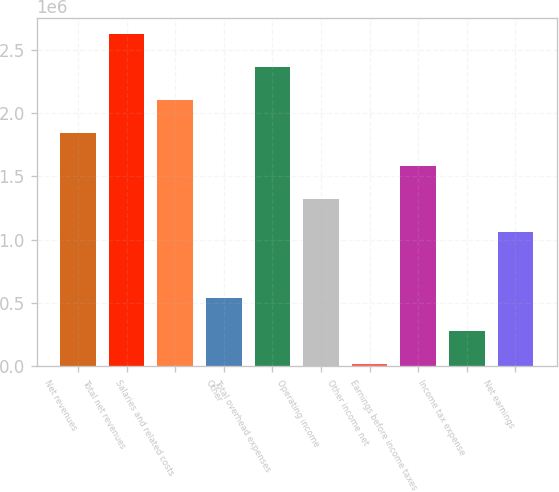<chart> <loc_0><loc_0><loc_500><loc_500><bar_chart><fcel>Net revenues<fcel>Total net revenues<fcel>Salaries and related costs<fcel>Other<fcel>Total overhead expenses<fcel>Operating income<fcel>Other income net<fcel>Earnings before income taxes<fcel>Income tax expense<fcel>Net earnings<nl><fcel>1.84079e+06<fcel>2.62037e+06<fcel>2.10065e+06<fcel>541487<fcel>2.36051e+06<fcel>1.32107e+06<fcel>21766<fcel>1.58093e+06<fcel>281627<fcel>1.06121e+06<nl></chart> 